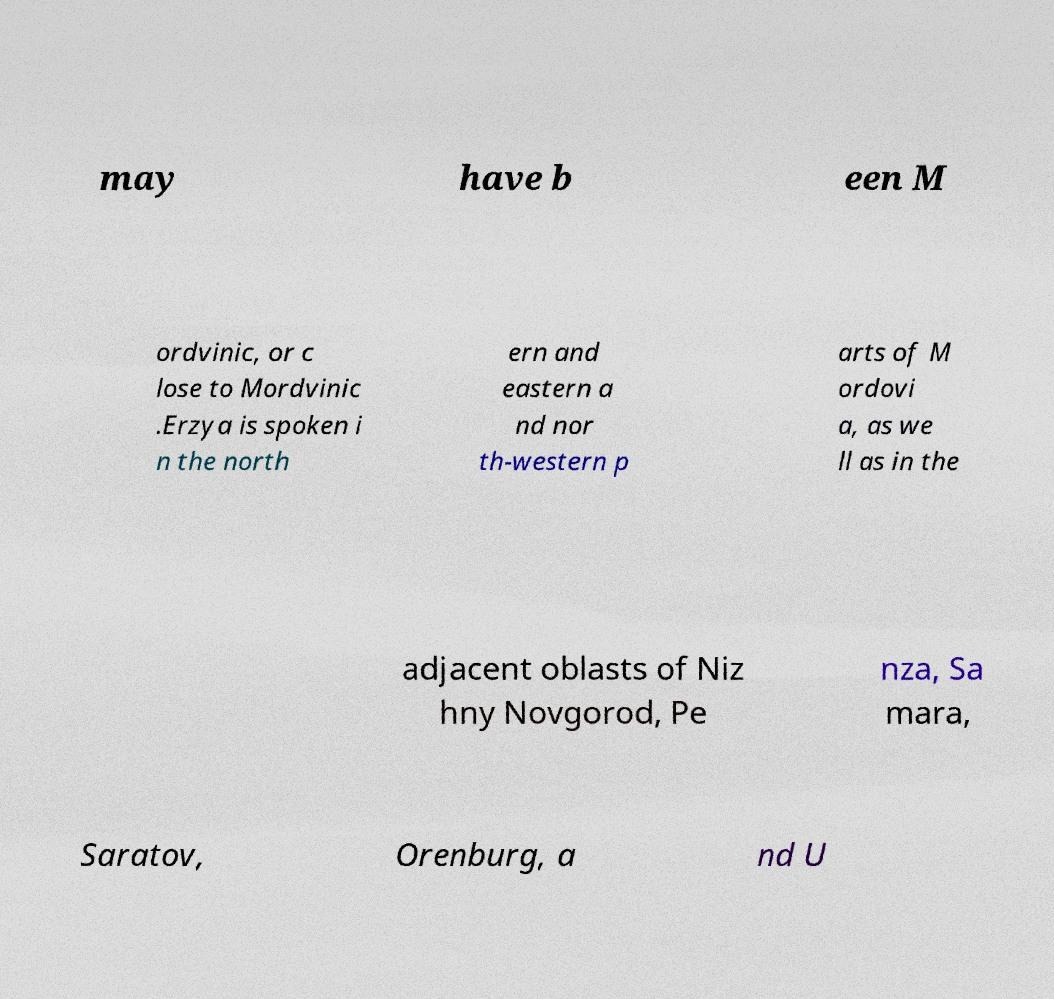There's text embedded in this image that I need extracted. Can you transcribe it verbatim? may have b een M ordvinic, or c lose to Mordvinic .Erzya is spoken i n the north ern and eastern a nd nor th-western p arts of M ordovi a, as we ll as in the adjacent oblasts of Niz hny Novgorod, Pe nza, Sa mara, Saratov, Orenburg, a nd U 